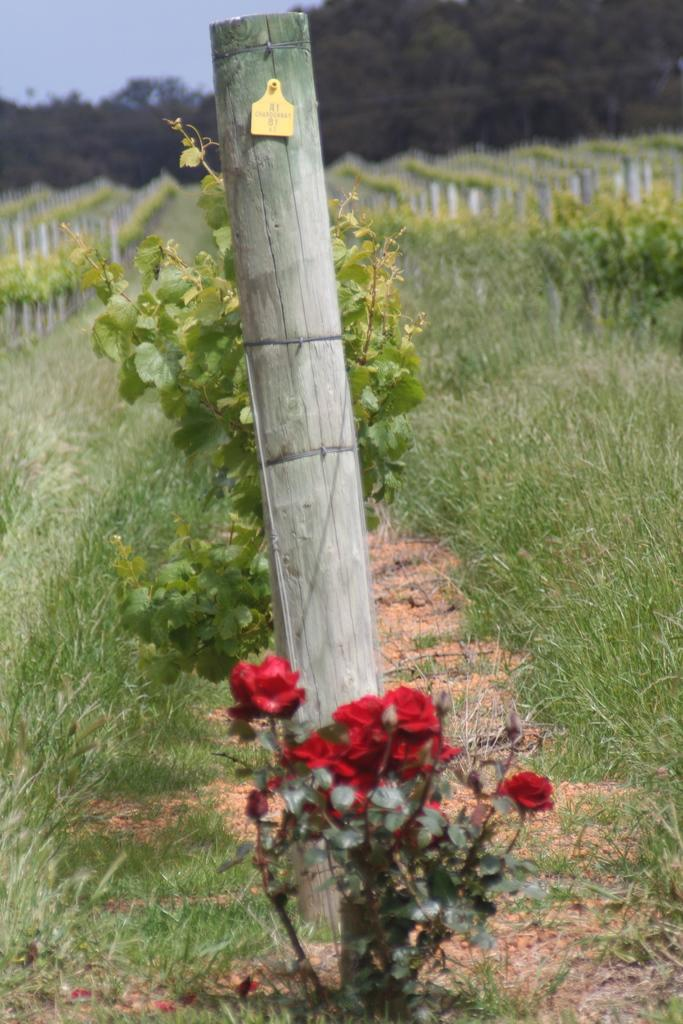What type of plant can be seen in the image? There is a flower plant in the image. Are there any other plants visible in the image? Yes, there are plants in the image. What type of ground cover is present in the image? There is grass in the image. What is on a wooden object in the image? There is a sticker on a wooden object in the image. What can be seen in the background of the image? There are trees and the sky visible in the background of the image. How does the memory affect the control of the yoke in the image? There is no yoke present in the image, and therefore no control or memory can be associated with it. 